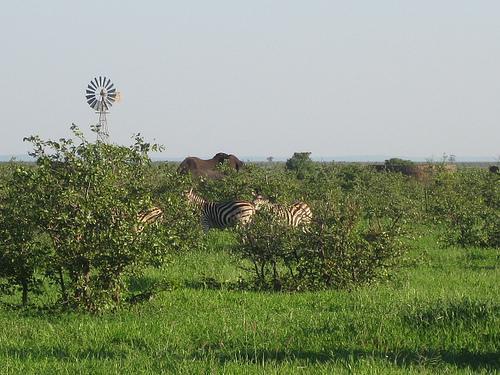How many chairs do you see?
Give a very brief answer. 0. 